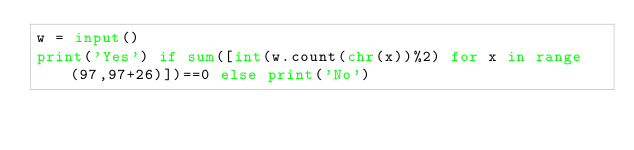<code> <loc_0><loc_0><loc_500><loc_500><_Python_>w = input()
print('Yes') if sum([int(w.count(chr(x))%2) for x in range(97,97+26)])==0 else print('No')</code> 